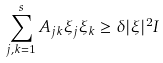<formula> <loc_0><loc_0><loc_500><loc_500>\sum _ { j , k = 1 } ^ { s } A _ { j k } \xi _ { j } \xi _ { k } \geq \delta | \xi | ^ { 2 } I</formula> 